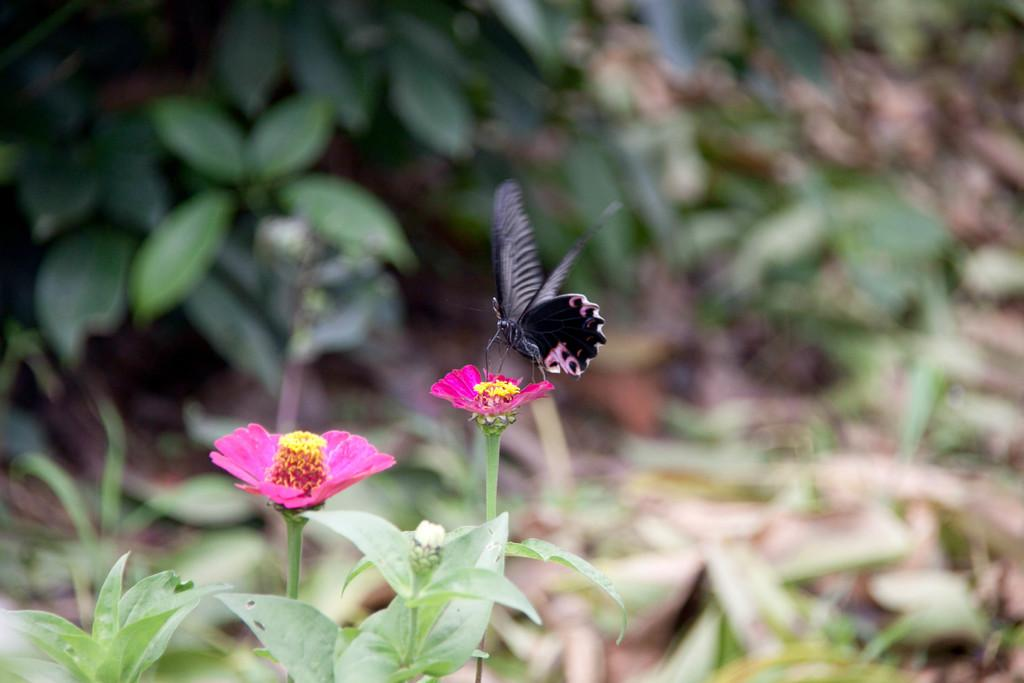What type of plants are on the left side of the image? There are plants with flowers on the left side of the image. What is present on one of the flowers? There is a butterfly on one of the flowers. Can you describe the background of the image? The background of the image is blurred. What is the level of quiet in the image? The level of quiet cannot be determined from the image, as it does not contain any auditory information. 